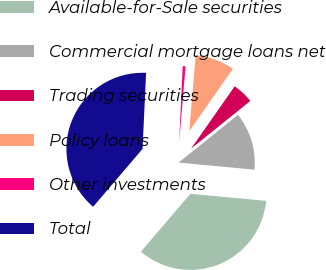<chart> <loc_0><loc_0><loc_500><loc_500><pie_chart><fcel>Available-for-Sale securities<fcel>Commercial mortgage loans net<fcel>Trading securities<fcel>Policy loans<fcel>Other investments<fcel>Total<nl><fcel>34.77%<fcel>12.27%<fcel>4.49%<fcel>8.38%<fcel>0.6%<fcel>39.5%<nl></chart> 